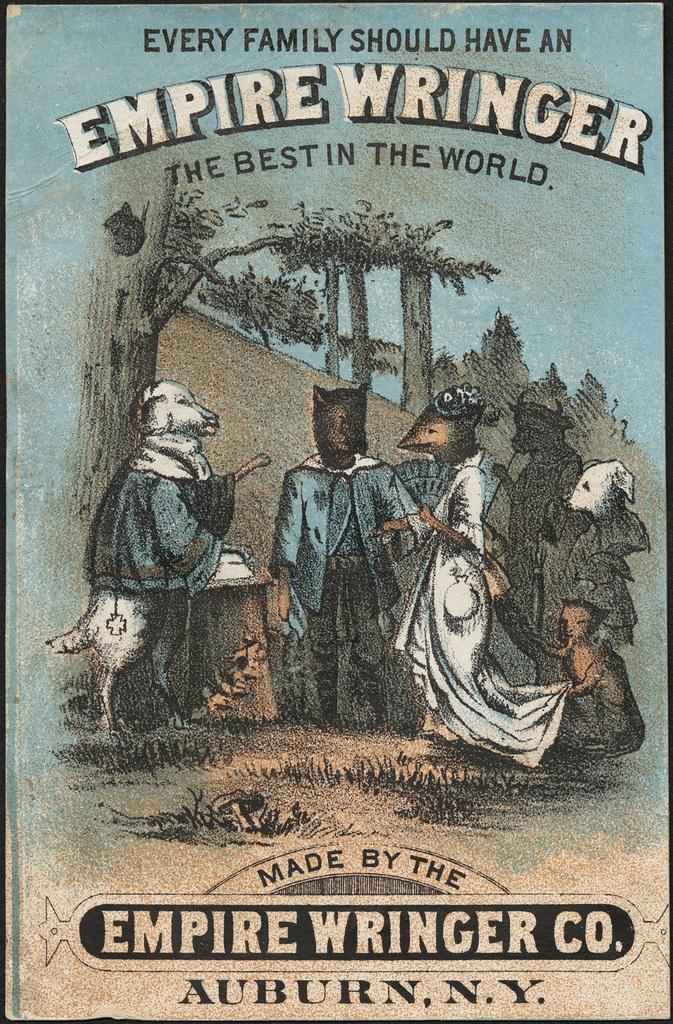What is the main subject of the image? The main subject of the image is a book cover. What type of coal is being used to power the balloon in the image? There is no coal or balloon present in the image; it features a book cover. How many tickets can be seen on the book cover in the image? There are no tickets present on the book cover in the image. 